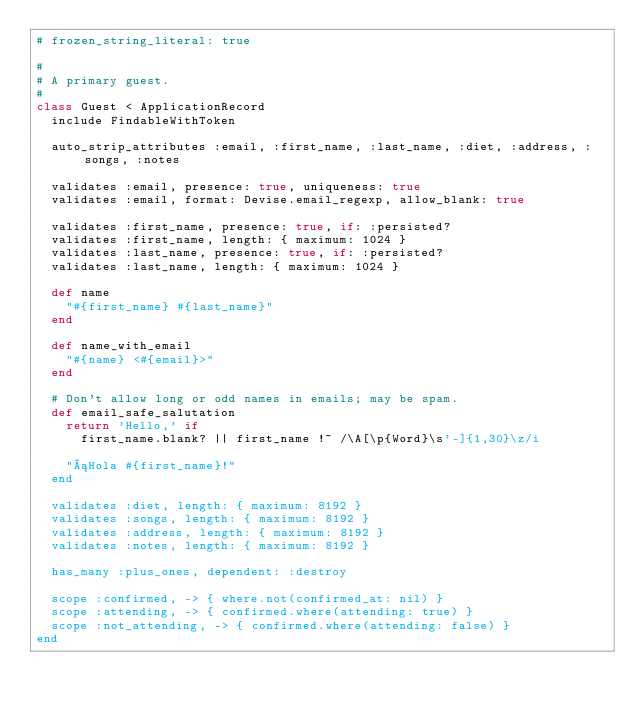<code> <loc_0><loc_0><loc_500><loc_500><_Ruby_># frozen_string_literal: true

#
# A primary guest.
#
class Guest < ApplicationRecord
  include FindableWithToken

  auto_strip_attributes :email, :first_name, :last_name, :diet, :address, :songs, :notes

  validates :email, presence: true, uniqueness: true
  validates :email, format: Devise.email_regexp, allow_blank: true

  validates :first_name, presence: true, if: :persisted?
  validates :first_name, length: { maximum: 1024 }
  validates :last_name, presence: true, if: :persisted?
  validates :last_name, length: { maximum: 1024 }

  def name
    "#{first_name} #{last_name}"
  end

  def name_with_email
    "#{name} <#{email}>"
  end

  # Don't allow long or odd names in emails; may be spam.
  def email_safe_salutation
    return 'Hello,' if
      first_name.blank? || first_name !~ /\A[\p{Word}\s'-]{1,30}\z/i

    "¡Hola #{first_name}!"
  end

  validates :diet, length: { maximum: 8192 }
  validates :songs, length: { maximum: 8192 }
  validates :address, length: { maximum: 8192 }
  validates :notes, length: { maximum: 8192 }

  has_many :plus_ones, dependent: :destroy

  scope :confirmed, -> { where.not(confirmed_at: nil) }
  scope :attending, -> { confirmed.where(attending: true) }
  scope :not_attending, -> { confirmed.where(attending: false) }
end
</code> 